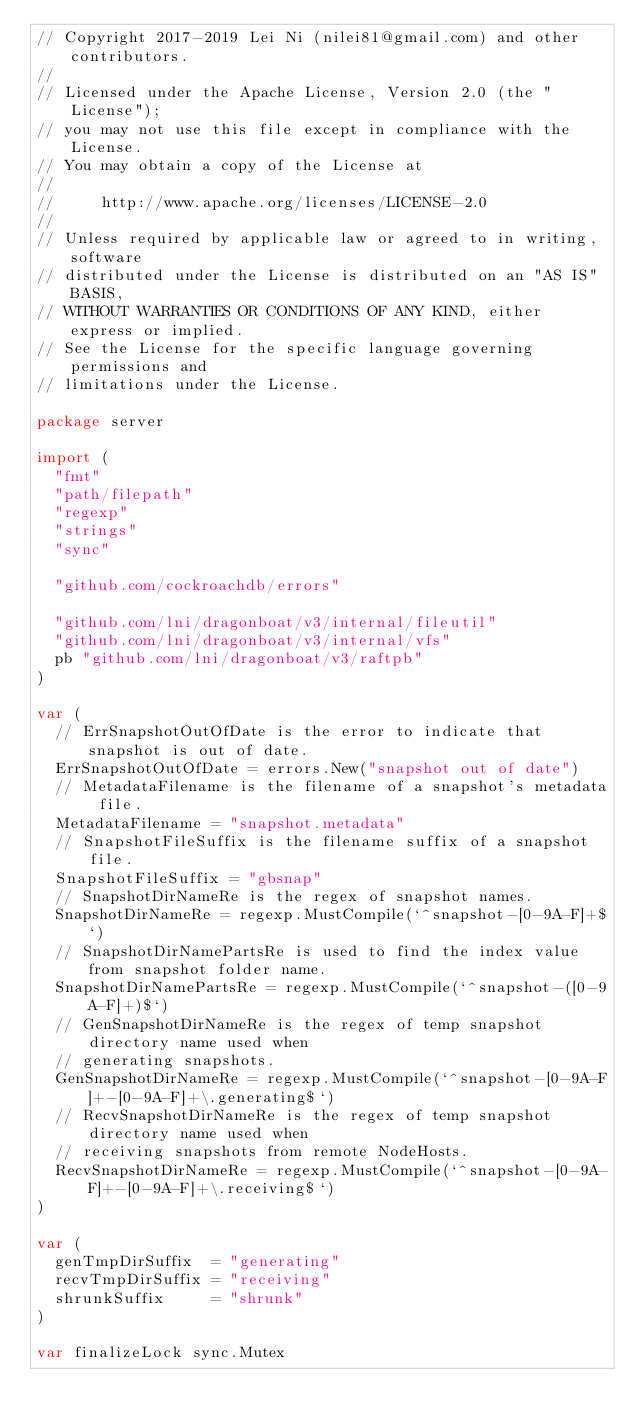<code> <loc_0><loc_0><loc_500><loc_500><_Go_>// Copyright 2017-2019 Lei Ni (nilei81@gmail.com) and other contributors.
//
// Licensed under the Apache License, Version 2.0 (the "License");
// you may not use this file except in compliance with the License.
// You may obtain a copy of the License at
//
//     http://www.apache.org/licenses/LICENSE-2.0
//
// Unless required by applicable law or agreed to in writing, software
// distributed under the License is distributed on an "AS IS" BASIS,
// WITHOUT WARRANTIES OR CONDITIONS OF ANY KIND, either express or implied.
// See the License for the specific language governing permissions and
// limitations under the License.

package server

import (
	"fmt"
	"path/filepath"
	"regexp"
	"strings"
	"sync"

	"github.com/cockroachdb/errors"

	"github.com/lni/dragonboat/v3/internal/fileutil"
	"github.com/lni/dragonboat/v3/internal/vfs"
	pb "github.com/lni/dragonboat/v3/raftpb"
)

var (
	// ErrSnapshotOutOfDate is the error to indicate that snapshot is out of date.
	ErrSnapshotOutOfDate = errors.New("snapshot out of date")
	// MetadataFilename is the filename of a snapshot's metadata file.
	MetadataFilename = "snapshot.metadata"
	// SnapshotFileSuffix is the filename suffix of a snapshot file.
	SnapshotFileSuffix = "gbsnap"
	// SnapshotDirNameRe is the regex of snapshot names.
	SnapshotDirNameRe = regexp.MustCompile(`^snapshot-[0-9A-F]+$`)
	// SnapshotDirNamePartsRe is used to find the index value from snapshot folder name.
	SnapshotDirNamePartsRe = regexp.MustCompile(`^snapshot-([0-9A-F]+)$`)
	// GenSnapshotDirNameRe is the regex of temp snapshot directory name used when
	// generating snapshots.
	GenSnapshotDirNameRe = regexp.MustCompile(`^snapshot-[0-9A-F]+-[0-9A-F]+\.generating$`)
	// RecvSnapshotDirNameRe is the regex of temp snapshot directory name used when
	// receiving snapshots from remote NodeHosts.
	RecvSnapshotDirNameRe = regexp.MustCompile(`^snapshot-[0-9A-F]+-[0-9A-F]+\.receiving$`)
)

var (
	genTmpDirSuffix  = "generating"
	recvTmpDirSuffix = "receiving"
	shrunkSuffix     = "shrunk"
)

var finalizeLock sync.Mutex
</code> 